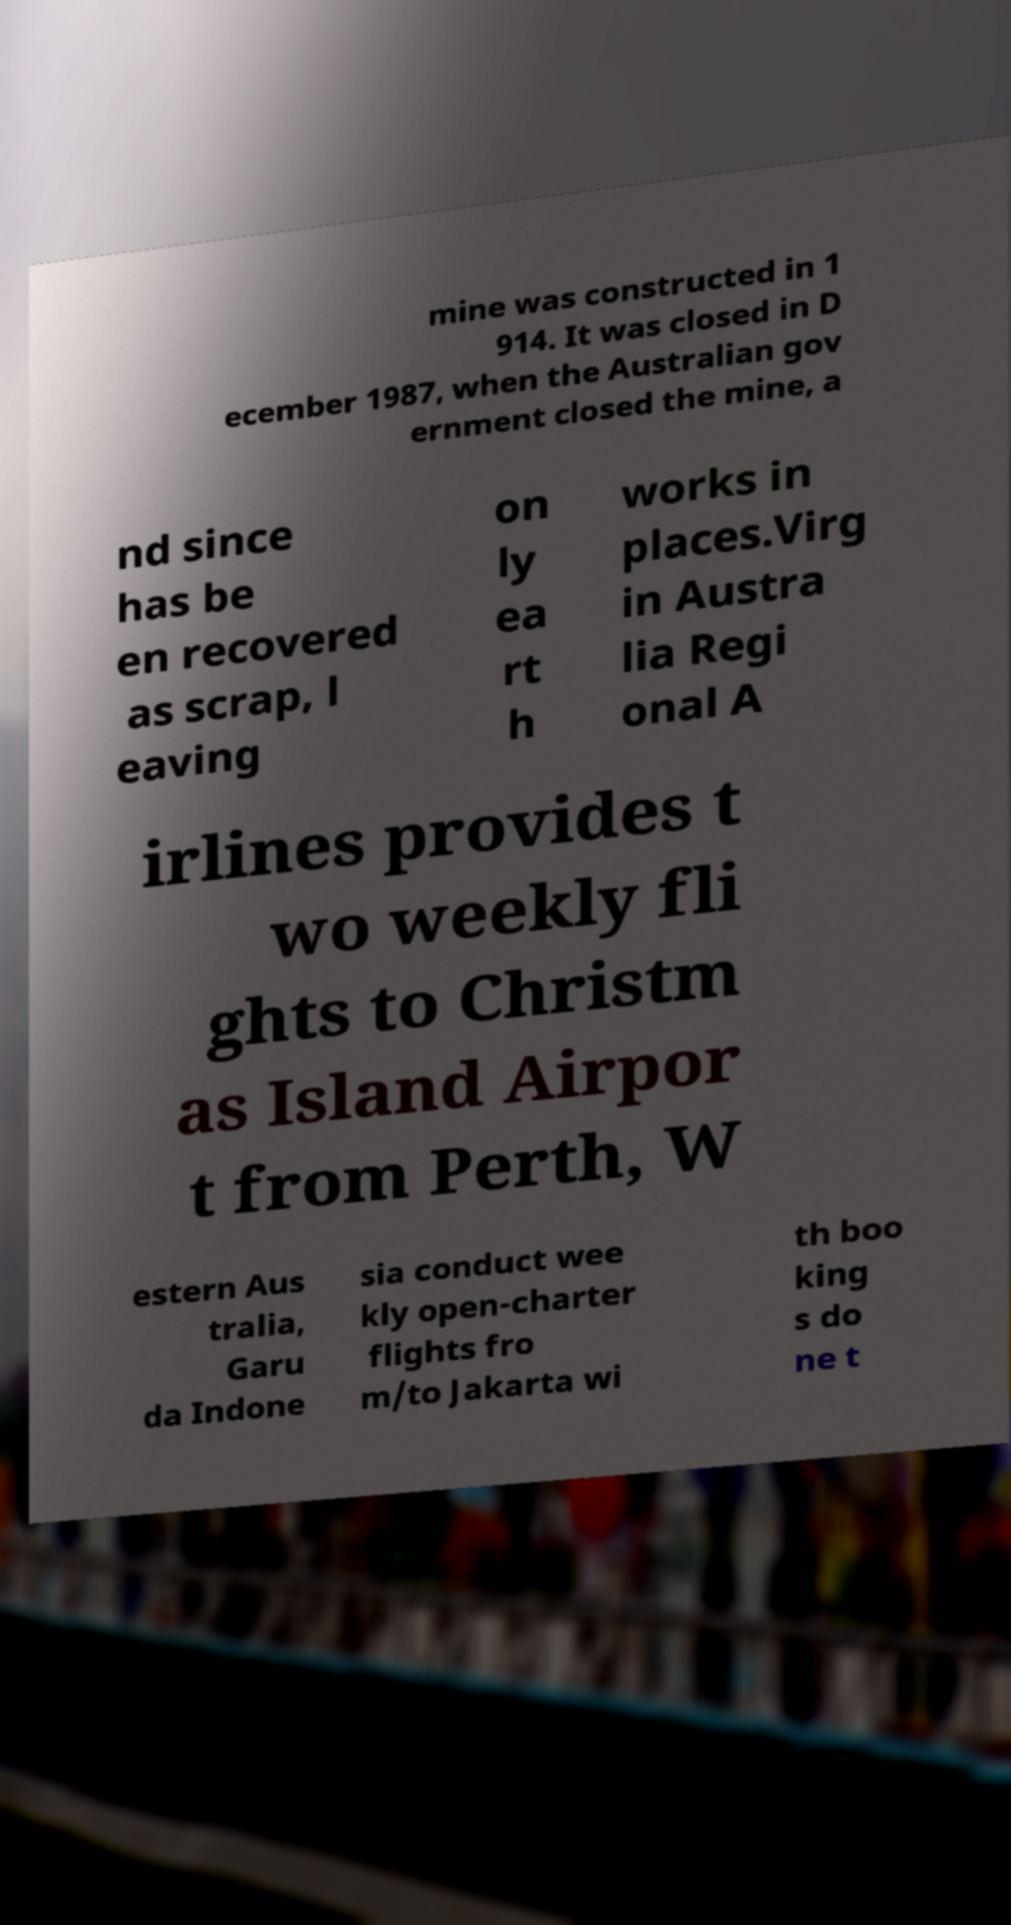Please identify and transcribe the text found in this image. mine was constructed in 1 914. It was closed in D ecember 1987, when the Australian gov ernment closed the mine, a nd since has be en recovered as scrap, l eaving on ly ea rt h works in places.Virg in Austra lia Regi onal A irlines provides t wo weekly fli ghts to Christm as Island Airpor t from Perth, W estern Aus tralia, Garu da Indone sia conduct wee kly open-charter flights fro m/to Jakarta wi th boo king s do ne t 